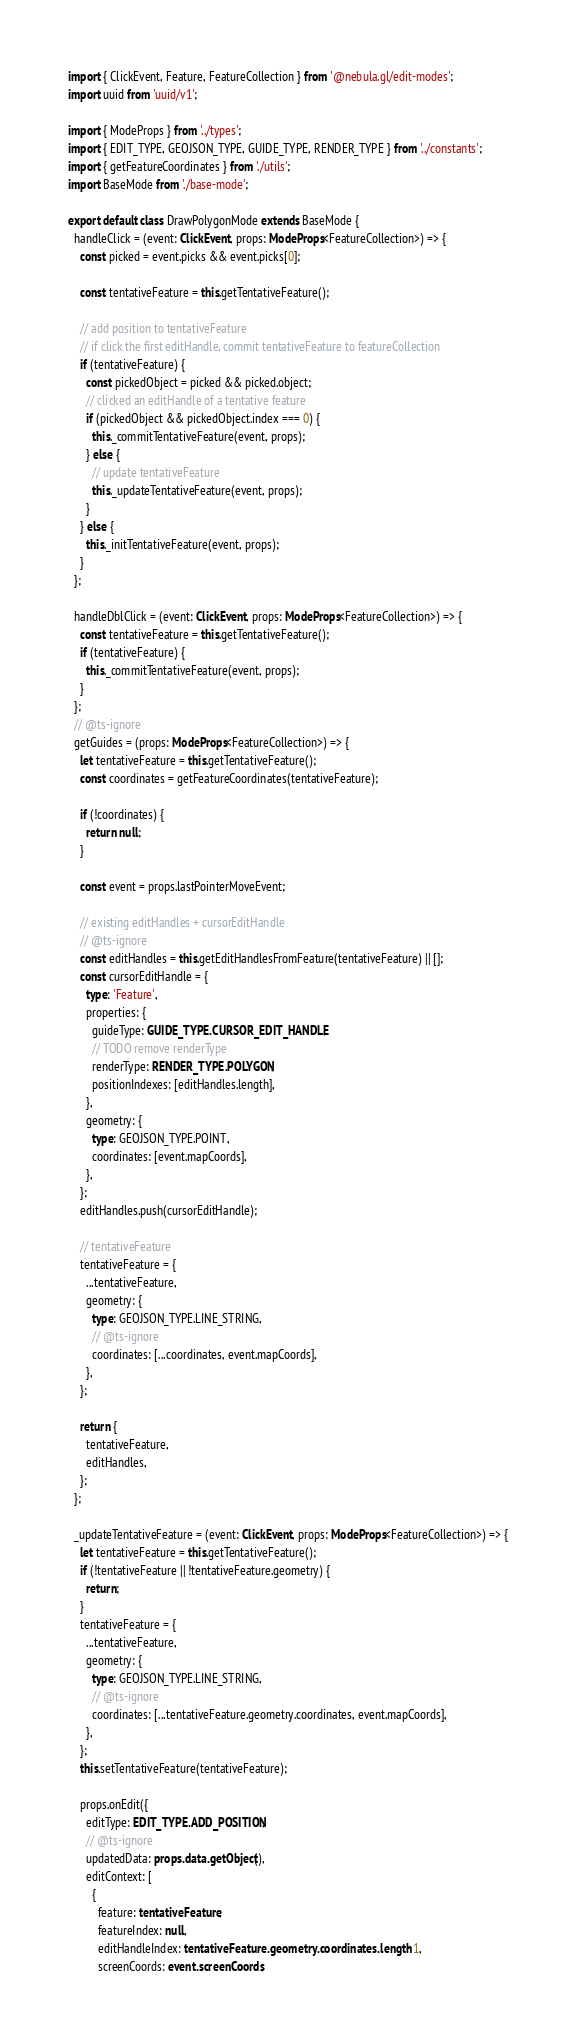Convert code to text. <code><loc_0><loc_0><loc_500><loc_500><_TypeScript_>import { ClickEvent, Feature, FeatureCollection } from '@nebula.gl/edit-modes';
import uuid from 'uuid/v1';

import { ModeProps } from '../types';
import { EDIT_TYPE, GEOJSON_TYPE, GUIDE_TYPE, RENDER_TYPE } from '../constants';
import { getFeatureCoordinates } from './utils';
import BaseMode from './base-mode';

export default class DrawPolygonMode extends BaseMode {
  handleClick = (event: ClickEvent, props: ModeProps<FeatureCollection>) => {
    const picked = event.picks && event.picks[0];

    const tentativeFeature = this.getTentativeFeature();

    // add position to tentativeFeature
    // if click the first editHandle, commit tentativeFeature to featureCollection
    if (tentativeFeature) {
      const pickedObject = picked && picked.object;
      // clicked an editHandle of a tentative feature
      if (pickedObject && pickedObject.index === 0) {
        this._commitTentativeFeature(event, props);
      } else {
        // update tentativeFeature
        this._updateTentativeFeature(event, props);
      }
    } else {
      this._initTentativeFeature(event, props);
    }
  };

  handleDblClick = (event: ClickEvent, props: ModeProps<FeatureCollection>) => {
    const tentativeFeature = this.getTentativeFeature();
    if (tentativeFeature) {
      this._commitTentativeFeature(event, props);
    }
  };
  // @ts-ignore
  getGuides = (props: ModeProps<FeatureCollection>) => {
    let tentativeFeature = this.getTentativeFeature();
    const coordinates = getFeatureCoordinates(tentativeFeature);

    if (!coordinates) {
      return null;
    }

    const event = props.lastPointerMoveEvent;

    // existing editHandles + cursorEditHandle
    // @ts-ignore
    const editHandles = this.getEditHandlesFromFeature(tentativeFeature) || [];
    const cursorEditHandle = {
      type: 'Feature',
      properties: {
        guideType: GUIDE_TYPE.CURSOR_EDIT_HANDLE,
        // TODO remove renderType
        renderType: RENDER_TYPE.POLYGON,
        positionIndexes: [editHandles.length],
      },
      geometry: {
        type: GEOJSON_TYPE.POINT,
        coordinates: [event.mapCoords],
      },
    };
    editHandles.push(cursorEditHandle);

    // tentativeFeature
    tentativeFeature = {
      ...tentativeFeature,
      geometry: {
        type: GEOJSON_TYPE.LINE_STRING,
        // @ts-ignore
        coordinates: [...coordinates, event.mapCoords],
      },
    };

    return {
      tentativeFeature,
      editHandles,
    };
  };

  _updateTentativeFeature = (event: ClickEvent, props: ModeProps<FeatureCollection>) => {
    let tentativeFeature = this.getTentativeFeature();
    if (!tentativeFeature || !tentativeFeature.geometry) {
      return;
    }
    tentativeFeature = {
      ...tentativeFeature,
      geometry: {
        type: GEOJSON_TYPE.LINE_STRING,
        // @ts-ignore
        coordinates: [...tentativeFeature.geometry.coordinates, event.mapCoords],
      },
    };
    this.setTentativeFeature(tentativeFeature);

    props.onEdit({
      editType: EDIT_TYPE.ADD_POSITION,
      // @ts-ignore
      updatedData: props.data.getObject(),
      editContext: [
        {
          feature: tentativeFeature,
          featureIndex: null,
          editHandleIndex: tentativeFeature.geometry.coordinates.length - 1,
          screenCoords: event.screenCoords,</code> 